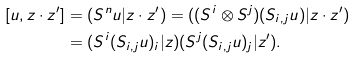<formula> <loc_0><loc_0><loc_500><loc_500>[ u , z \cdot z ^ { \prime } ] & = ( S ^ { n } u | z \cdot z ^ { \prime } ) = ( ( S ^ { i } \otimes S ^ { j } ) ( S _ { i , j } u ) | z \cdot z ^ { \prime } ) \\ & = ( S ^ { i } ( S _ { i , j } u ) _ { i } | z ) ( S ^ { j } ( S _ { i , j } u ) _ { j } | z ^ { \prime } ) .</formula> 